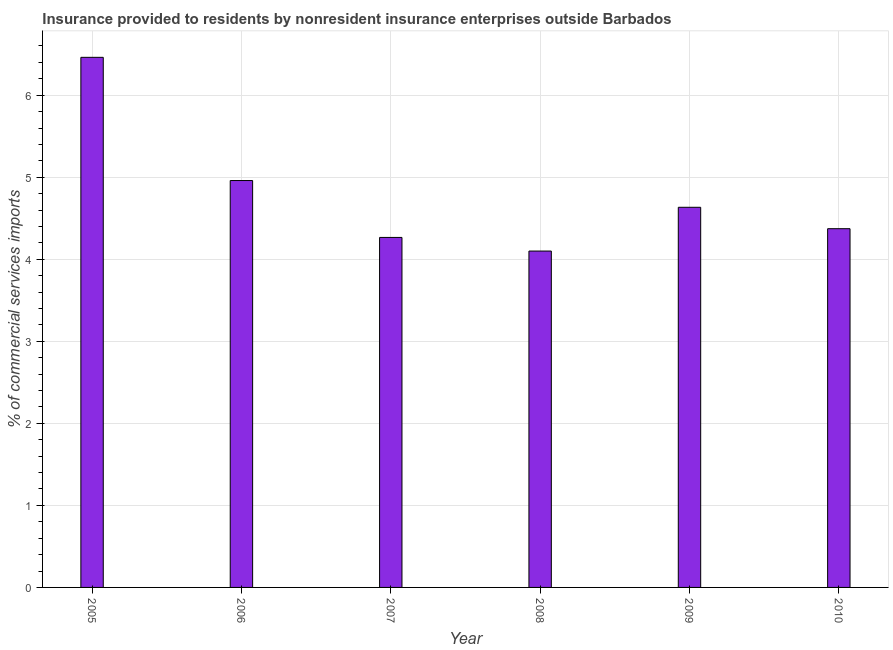Does the graph contain any zero values?
Offer a terse response. No. Does the graph contain grids?
Provide a succinct answer. Yes. What is the title of the graph?
Ensure brevity in your answer.  Insurance provided to residents by nonresident insurance enterprises outside Barbados. What is the label or title of the X-axis?
Provide a succinct answer. Year. What is the label or title of the Y-axis?
Ensure brevity in your answer.  % of commercial services imports. What is the insurance provided by non-residents in 2008?
Keep it short and to the point. 4.1. Across all years, what is the maximum insurance provided by non-residents?
Provide a short and direct response. 6.46. Across all years, what is the minimum insurance provided by non-residents?
Ensure brevity in your answer.  4.1. What is the sum of the insurance provided by non-residents?
Offer a very short reply. 28.79. What is the difference between the insurance provided by non-residents in 2005 and 2006?
Keep it short and to the point. 1.5. What is the average insurance provided by non-residents per year?
Your response must be concise. 4.8. What is the median insurance provided by non-residents?
Your answer should be very brief. 4.5. Do a majority of the years between 2009 and 2006 (inclusive) have insurance provided by non-residents greater than 0.4 %?
Make the answer very short. Yes. Is the insurance provided by non-residents in 2005 less than that in 2008?
Give a very brief answer. No. Is the difference between the insurance provided by non-residents in 2009 and 2010 greater than the difference between any two years?
Provide a short and direct response. No. What is the difference between the highest and the second highest insurance provided by non-residents?
Offer a terse response. 1.5. Is the sum of the insurance provided by non-residents in 2008 and 2009 greater than the maximum insurance provided by non-residents across all years?
Offer a terse response. Yes. What is the difference between the highest and the lowest insurance provided by non-residents?
Ensure brevity in your answer.  2.36. In how many years, is the insurance provided by non-residents greater than the average insurance provided by non-residents taken over all years?
Provide a short and direct response. 2. How many bars are there?
Offer a very short reply. 6. Are all the bars in the graph horizontal?
Give a very brief answer. No. What is the difference between two consecutive major ticks on the Y-axis?
Ensure brevity in your answer.  1. Are the values on the major ticks of Y-axis written in scientific E-notation?
Your response must be concise. No. What is the % of commercial services imports of 2005?
Provide a succinct answer. 6.46. What is the % of commercial services imports in 2006?
Your response must be concise. 4.96. What is the % of commercial services imports in 2007?
Provide a short and direct response. 4.27. What is the % of commercial services imports of 2008?
Make the answer very short. 4.1. What is the % of commercial services imports of 2009?
Give a very brief answer. 4.63. What is the % of commercial services imports in 2010?
Give a very brief answer. 4.37. What is the difference between the % of commercial services imports in 2005 and 2006?
Provide a short and direct response. 1.5. What is the difference between the % of commercial services imports in 2005 and 2007?
Make the answer very short. 2.2. What is the difference between the % of commercial services imports in 2005 and 2008?
Your answer should be compact. 2.36. What is the difference between the % of commercial services imports in 2005 and 2009?
Ensure brevity in your answer.  1.83. What is the difference between the % of commercial services imports in 2005 and 2010?
Your answer should be very brief. 2.09. What is the difference between the % of commercial services imports in 2006 and 2007?
Keep it short and to the point. 0.69. What is the difference between the % of commercial services imports in 2006 and 2008?
Your answer should be very brief. 0.86. What is the difference between the % of commercial services imports in 2006 and 2009?
Provide a succinct answer. 0.33. What is the difference between the % of commercial services imports in 2006 and 2010?
Your answer should be compact. 0.59. What is the difference between the % of commercial services imports in 2007 and 2008?
Your answer should be compact. 0.17. What is the difference between the % of commercial services imports in 2007 and 2009?
Your answer should be very brief. -0.37. What is the difference between the % of commercial services imports in 2007 and 2010?
Your response must be concise. -0.11. What is the difference between the % of commercial services imports in 2008 and 2009?
Provide a succinct answer. -0.53. What is the difference between the % of commercial services imports in 2008 and 2010?
Keep it short and to the point. -0.27. What is the difference between the % of commercial services imports in 2009 and 2010?
Offer a terse response. 0.26. What is the ratio of the % of commercial services imports in 2005 to that in 2006?
Provide a succinct answer. 1.3. What is the ratio of the % of commercial services imports in 2005 to that in 2007?
Give a very brief answer. 1.51. What is the ratio of the % of commercial services imports in 2005 to that in 2008?
Your answer should be compact. 1.58. What is the ratio of the % of commercial services imports in 2005 to that in 2009?
Offer a very short reply. 1.39. What is the ratio of the % of commercial services imports in 2005 to that in 2010?
Provide a succinct answer. 1.48. What is the ratio of the % of commercial services imports in 2006 to that in 2007?
Provide a succinct answer. 1.16. What is the ratio of the % of commercial services imports in 2006 to that in 2008?
Ensure brevity in your answer.  1.21. What is the ratio of the % of commercial services imports in 2006 to that in 2009?
Your answer should be very brief. 1.07. What is the ratio of the % of commercial services imports in 2006 to that in 2010?
Your answer should be very brief. 1.13. What is the ratio of the % of commercial services imports in 2007 to that in 2008?
Give a very brief answer. 1.04. What is the ratio of the % of commercial services imports in 2007 to that in 2009?
Provide a short and direct response. 0.92. What is the ratio of the % of commercial services imports in 2007 to that in 2010?
Offer a terse response. 0.98. What is the ratio of the % of commercial services imports in 2008 to that in 2009?
Ensure brevity in your answer.  0.89. What is the ratio of the % of commercial services imports in 2008 to that in 2010?
Give a very brief answer. 0.94. What is the ratio of the % of commercial services imports in 2009 to that in 2010?
Make the answer very short. 1.06. 